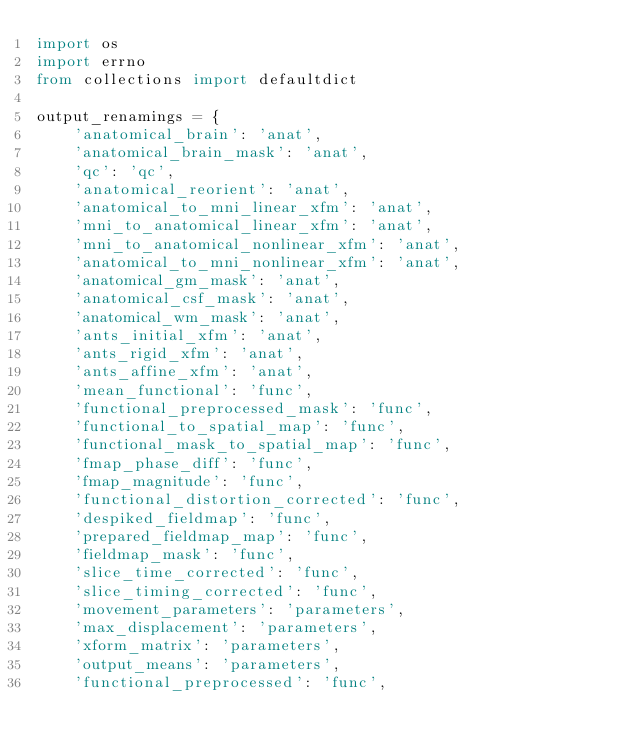<code> <loc_0><loc_0><loc_500><loc_500><_Python_>import os
import errno
from collections import defaultdict

output_renamings = {
    'anatomical_brain': 'anat',
    'anatomical_brain_mask': 'anat',
    'qc': 'qc',
    'anatomical_reorient': 'anat',
    'anatomical_to_mni_linear_xfm': 'anat',
    'mni_to_anatomical_linear_xfm': 'anat',
    'mni_to_anatomical_nonlinear_xfm': 'anat',
    'anatomical_to_mni_nonlinear_xfm': 'anat',
    'anatomical_gm_mask': 'anat',
    'anatomical_csf_mask': 'anat',
    'anatomical_wm_mask': 'anat',
    'ants_initial_xfm': 'anat',
    'ants_rigid_xfm': 'anat',
    'ants_affine_xfm': 'anat',
    'mean_functional': 'func',
    'functional_preprocessed_mask': 'func',
    'functional_to_spatial_map': 'func',
    'functional_mask_to_spatial_map': 'func',
    'fmap_phase_diff': 'func',
    'fmap_magnitude': 'func',
    'functional_distortion_corrected': 'func',
    'despiked_fieldmap': 'func',
    'prepared_fieldmap_map': 'func',
    'fieldmap_mask': 'func',
    'slice_time_corrected': 'func',
    'slice_timing_corrected': 'func',
    'movement_parameters': 'parameters',
    'max_displacement': 'parameters',
    'xform_matrix': 'parameters',
    'output_means': 'parameters',
    'functional_preprocessed': 'func',</code> 